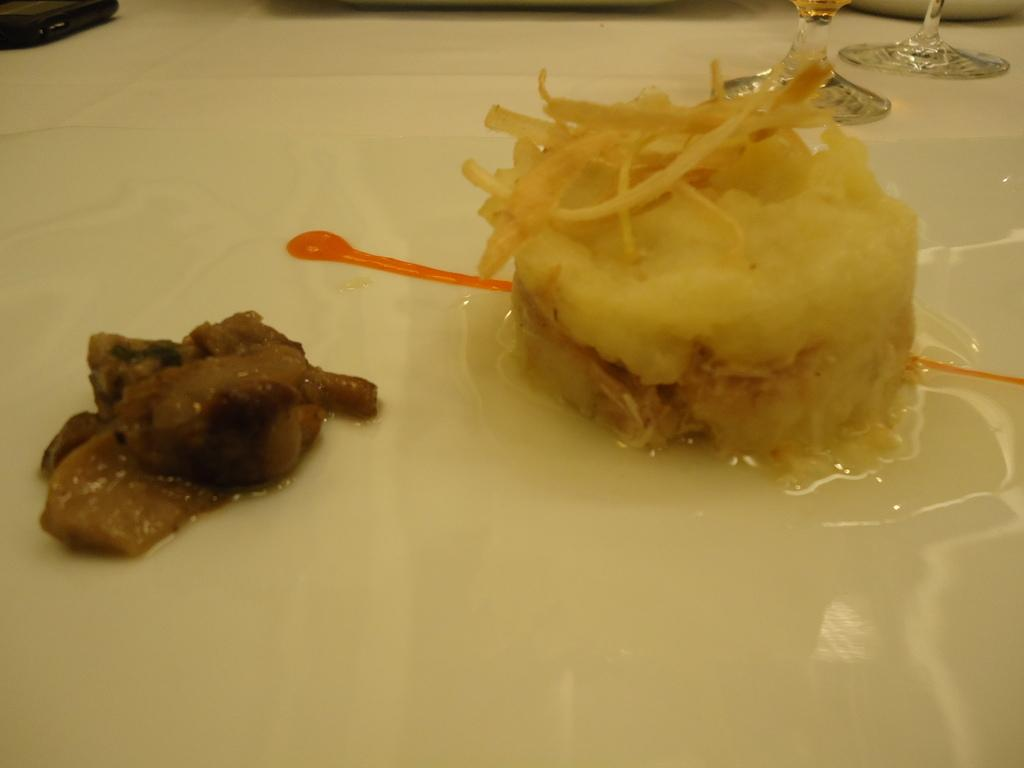What type of surface are the food items placed on in the image? The food items are placed on a white surface in the image. What else can be seen in the image besides the food items? There are glasses in the image. Can you describe the black object in the top left corner of the image? There is a black object in the top left corner of the image. How does the image convey a sense of quiet in the scene? The image does not convey a sense of quiet, as there are no auditory or contextual clues to suggest the presence or absence of noise. 